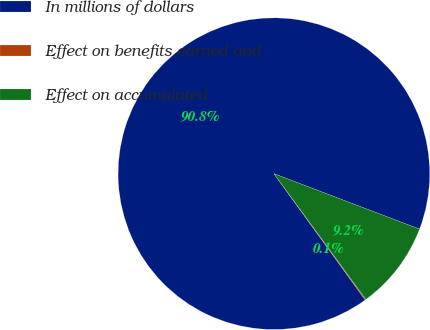<chart> <loc_0><loc_0><loc_500><loc_500><pie_chart><fcel>In millions of dollars<fcel>Effect on benefits earned and<fcel>Effect on accumulated<nl><fcel>90.75%<fcel>0.09%<fcel>9.16%<nl></chart> 